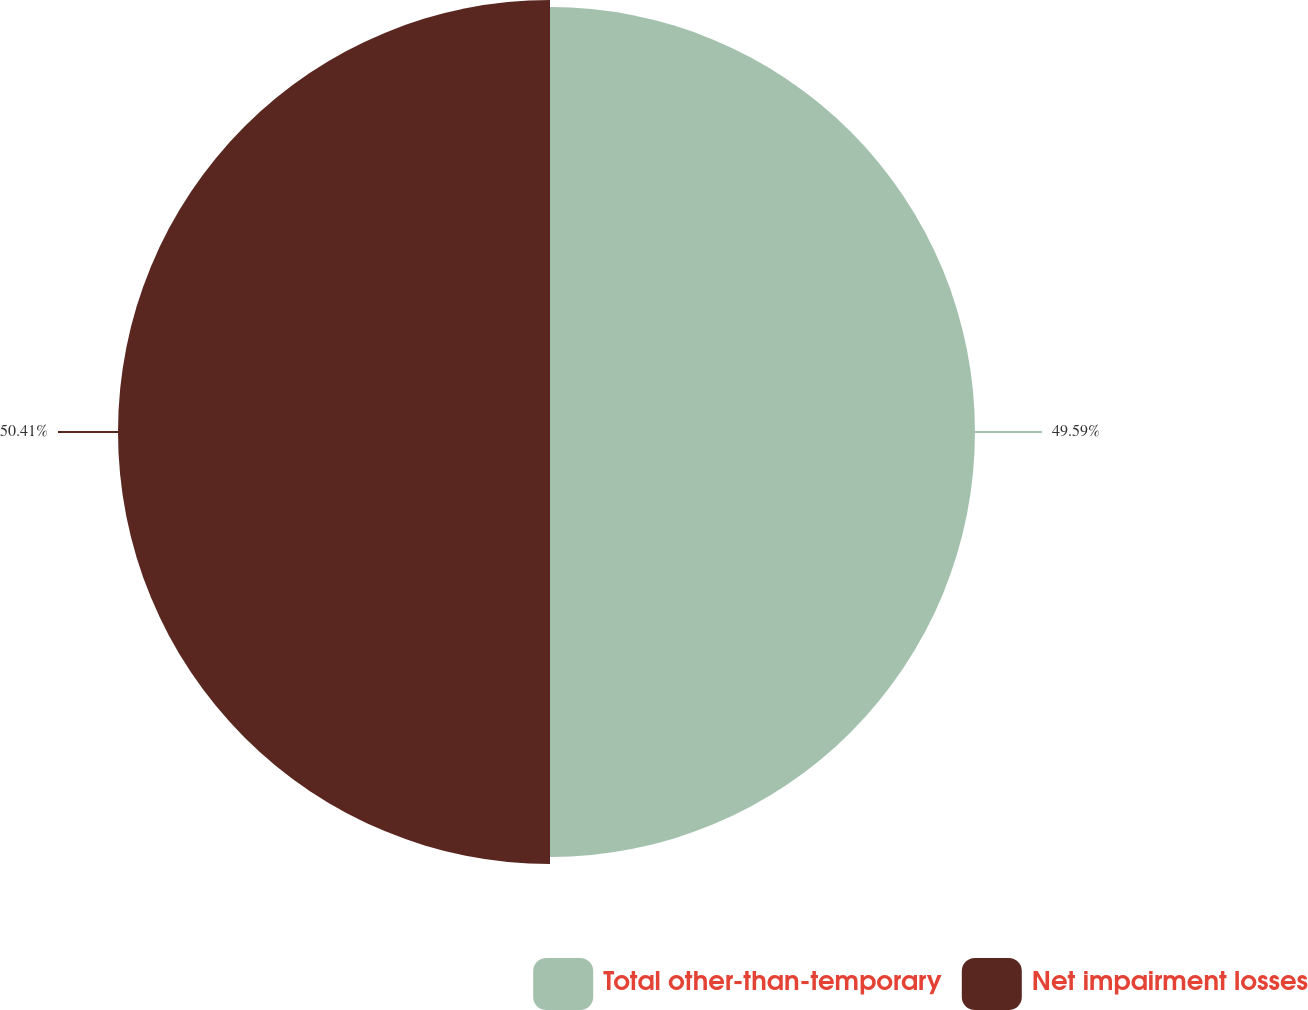Convert chart. <chart><loc_0><loc_0><loc_500><loc_500><pie_chart><fcel>Total other-than-temporary<fcel>Net impairment losses<nl><fcel>49.59%<fcel>50.41%<nl></chart> 